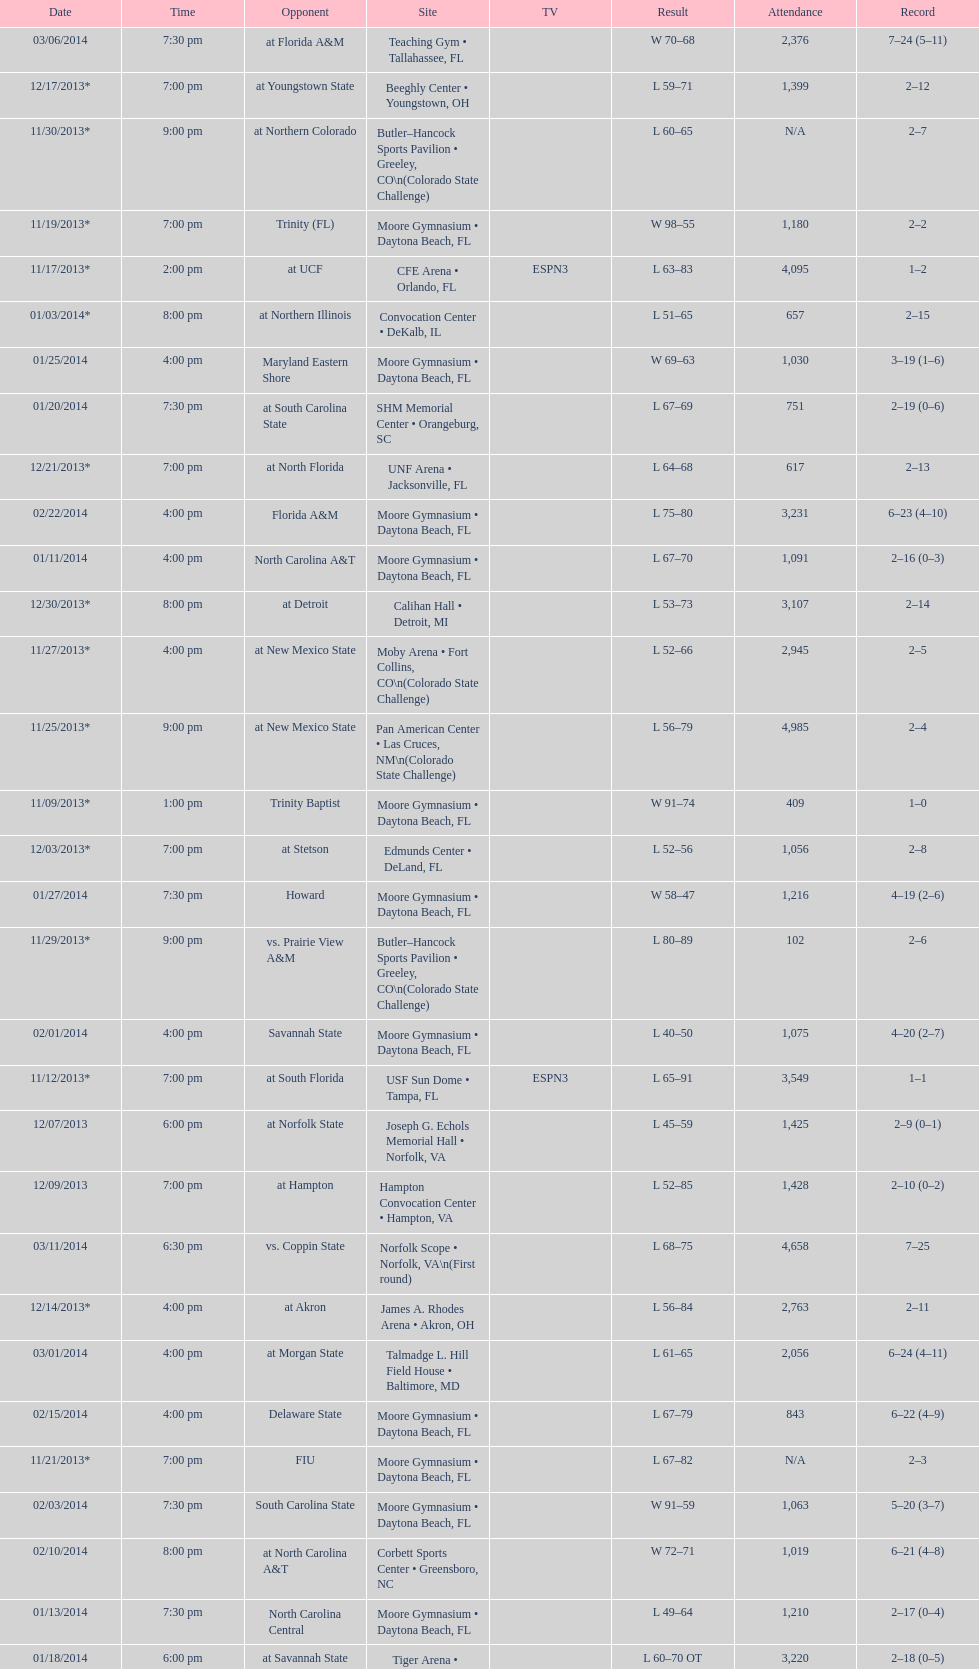Which game was won by a bigger margin, against trinity (fl) or against trinity baptist? Trinity (FL). 